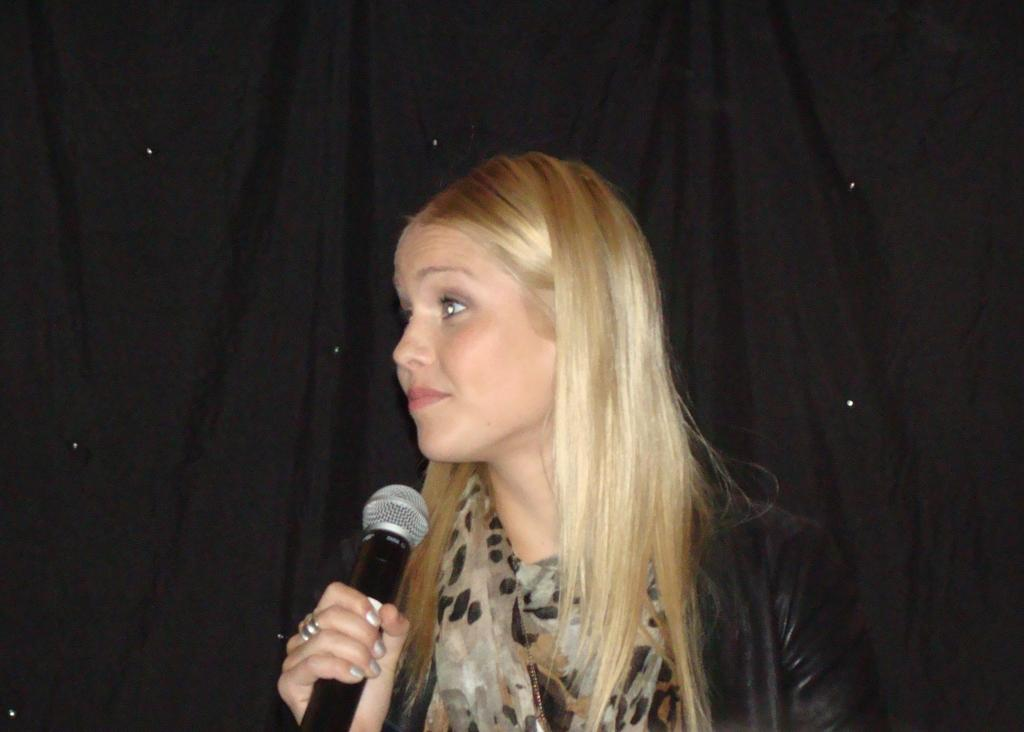Who is the main subject in the image? There is a woman in the image. What is the woman wearing? The woman is wearing a black skirt. What is the woman holding in her hand? The woman is holding a microphone in her hand. What can be seen in the background of the image? There is a black curtain in the background of the image. What type of vacation is the woman planning based on the image? There is no information about a vacation in the image, as it only shows a woman holding a microphone and wearing a black skirt with a black curtain in the background. 